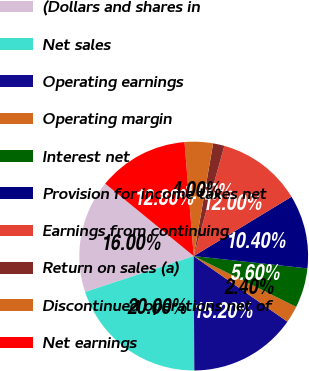Convert chart. <chart><loc_0><loc_0><loc_500><loc_500><pie_chart><fcel>(Dollars and shares in<fcel>Net sales<fcel>Operating earnings<fcel>Operating margin<fcel>Interest net<fcel>Provision for income taxes net<fcel>Earnings from continuing<fcel>Return on sales (a)<fcel>Discontinued operations net of<fcel>Net earnings<nl><fcel>16.0%<fcel>20.0%<fcel>15.2%<fcel>2.4%<fcel>5.6%<fcel>10.4%<fcel>12.0%<fcel>1.6%<fcel>4.0%<fcel>12.8%<nl></chart> 